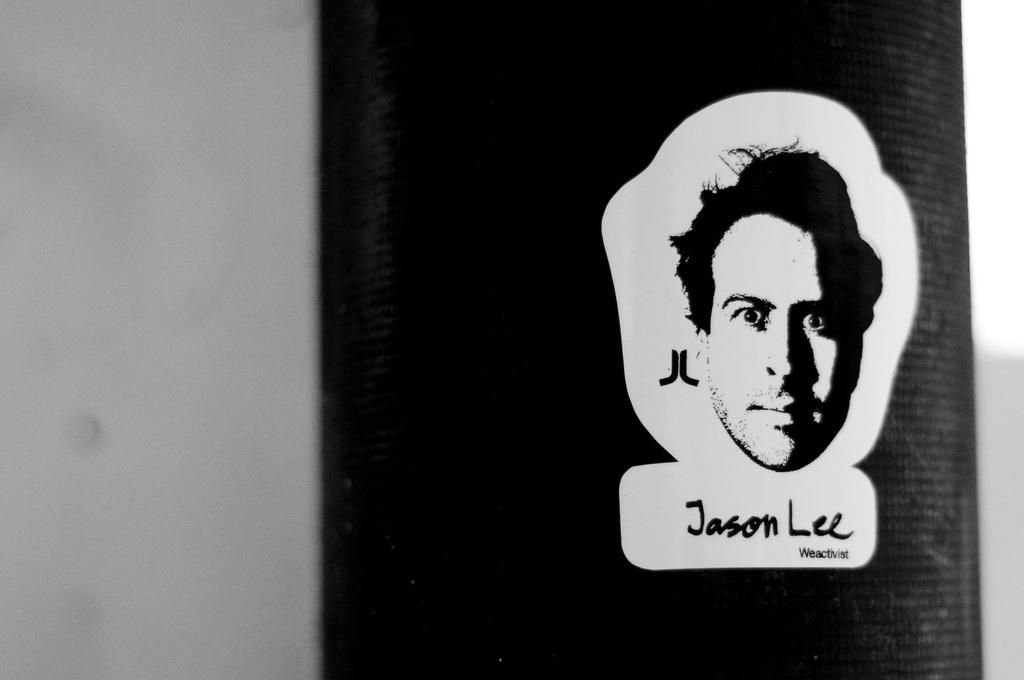What is the color scheme of the image? The image is black and white. What can be seen in the image? There is a person's head in the image. What is present below the person's head in the image? There is something written below the person's head in the image. Can you see a cap on the person's head in the image? There is no cap visible on the person's head in the image. How many cables are connected to the person's head in the image? There are no cables present in the image. 